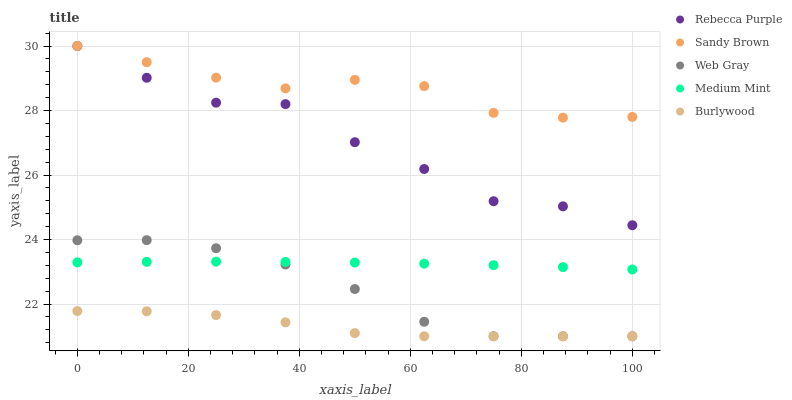Does Burlywood have the minimum area under the curve?
Answer yes or no. Yes. Does Sandy Brown have the maximum area under the curve?
Answer yes or no. Yes. Does Web Gray have the minimum area under the curve?
Answer yes or no. No. Does Web Gray have the maximum area under the curve?
Answer yes or no. No. Is Medium Mint the smoothest?
Answer yes or no. Yes. Is Rebecca Purple the roughest?
Answer yes or no. Yes. Is Burlywood the smoothest?
Answer yes or no. No. Is Burlywood the roughest?
Answer yes or no. No. Does Burlywood have the lowest value?
Answer yes or no. Yes. Does Sandy Brown have the lowest value?
Answer yes or no. No. Does Rebecca Purple have the highest value?
Answer yes or no. Yes. Does Web Gray have the highest value?
Answer yes or no. No. Is Burlywood less than Medium Mint?
Answer yes or no. Yes. Is Sandy Brown greater than Web Gray?
Answer yes or no. Yes. Does Web Gray intersect Burlywood?
Answer yes or no. Yes. Is Web Gray less than Burlywood?
Answer yes or no. No. Is Web Gray greater than Burlywood?
Answer yes or no. No. Does Burlywood intersect Medium Mint?
Answer yes or no. No. 